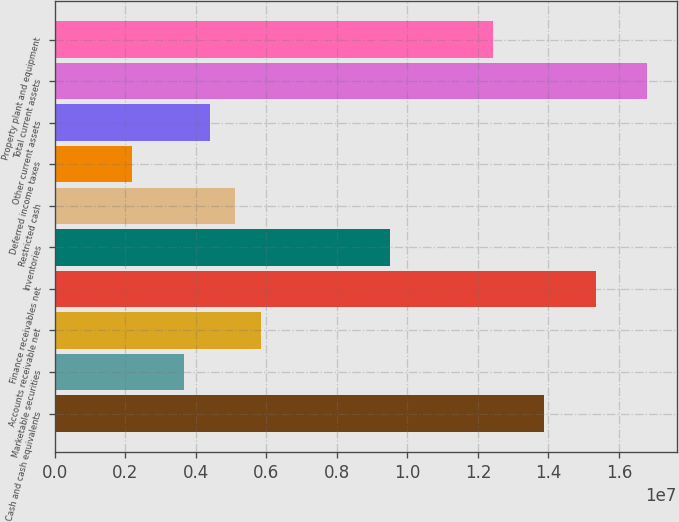<chart> <loc_0><loc_0><loc_500><loc_500><bar_chart><fcel>Cash and cash equivalents<fcel>Marketable securities<fcel>Accounts receivable net<fcel>Finance receivables net<fcel>Inventories<fcel>Restricted cash<fcel>Deferred income taxes<fcel>Other current assets<fcel>Total current assets<fcel>Property plant and equipment<nl><fcel>1.38791e+07<fcel>3.65492e+06<fcel>5.84582e+06<fcel>1.53397e+07<fcel>9.49733e+06<fcel>5.11552e+06<fcel>2.19432e+06<fcel>4.38522e+06<fcel>1.68003e+07<fcel>1.24185e+07<nl></chart> 